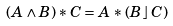<formula> <loc_0><loc_0><loc_500><loc_500>( A \wedge B ) * C = A * ( B \, \rfloor \, C )</formula> 